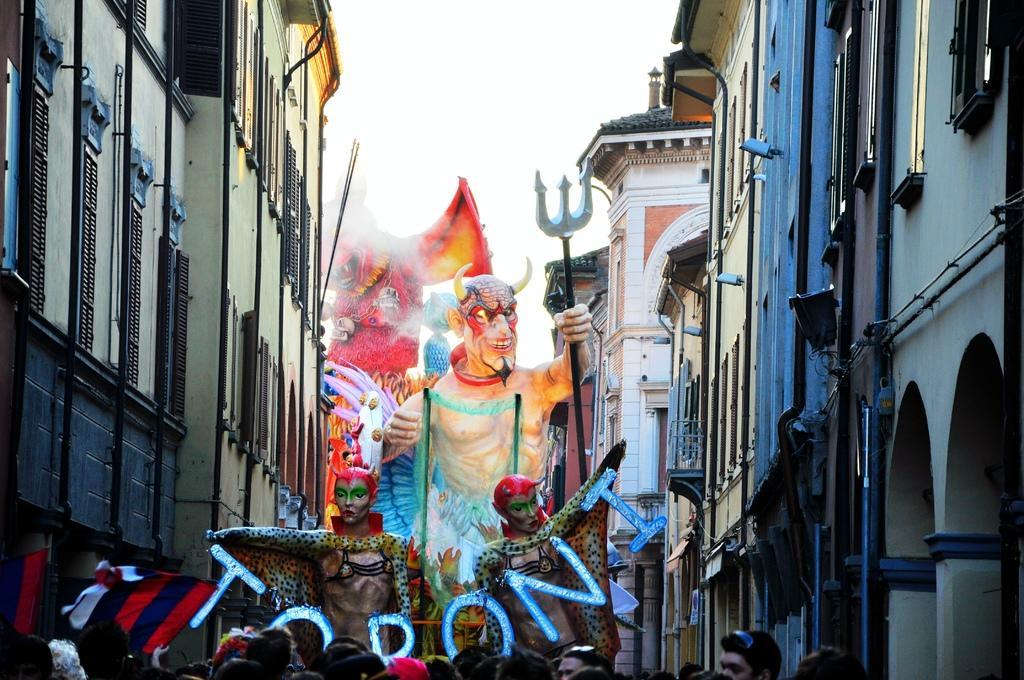Can you describe this image briefly? In this picture I can see there is a carnival and there are many people standing at the bottom of the image, there are huge idols and there are a few buildings at right and left sides. The sky is clear. 